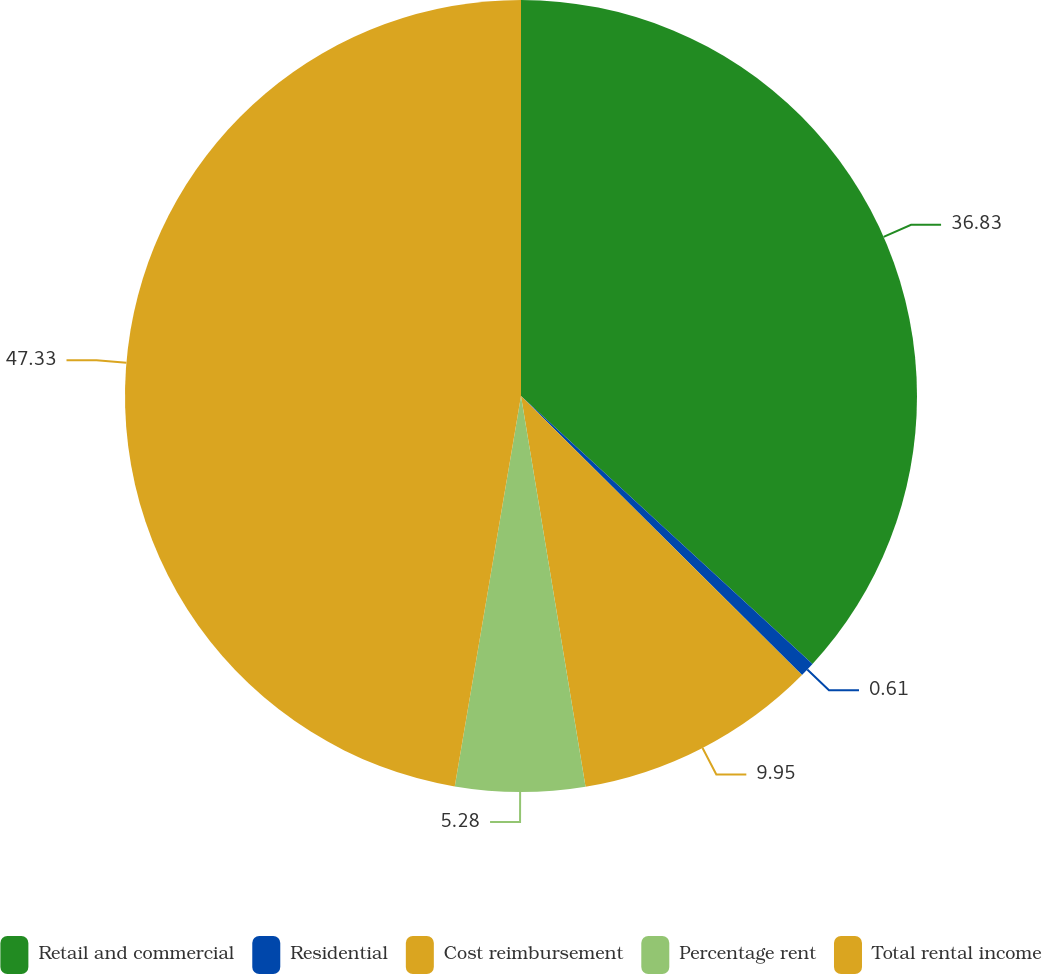Convert chart to OTSL. <chart><loc_0><loc_0><loc_500><loc_500><pie_chart><fcel>Retail and commercial<fcel>Residential<fcel>Cost reimbursement<fcel>Percentage rent<fcel>Total rental income<nl><fcel>36.83%<fcel>0.61%<fcel>9.95%<fcel>5.28%<fcel>47.32%<nl></chart> 